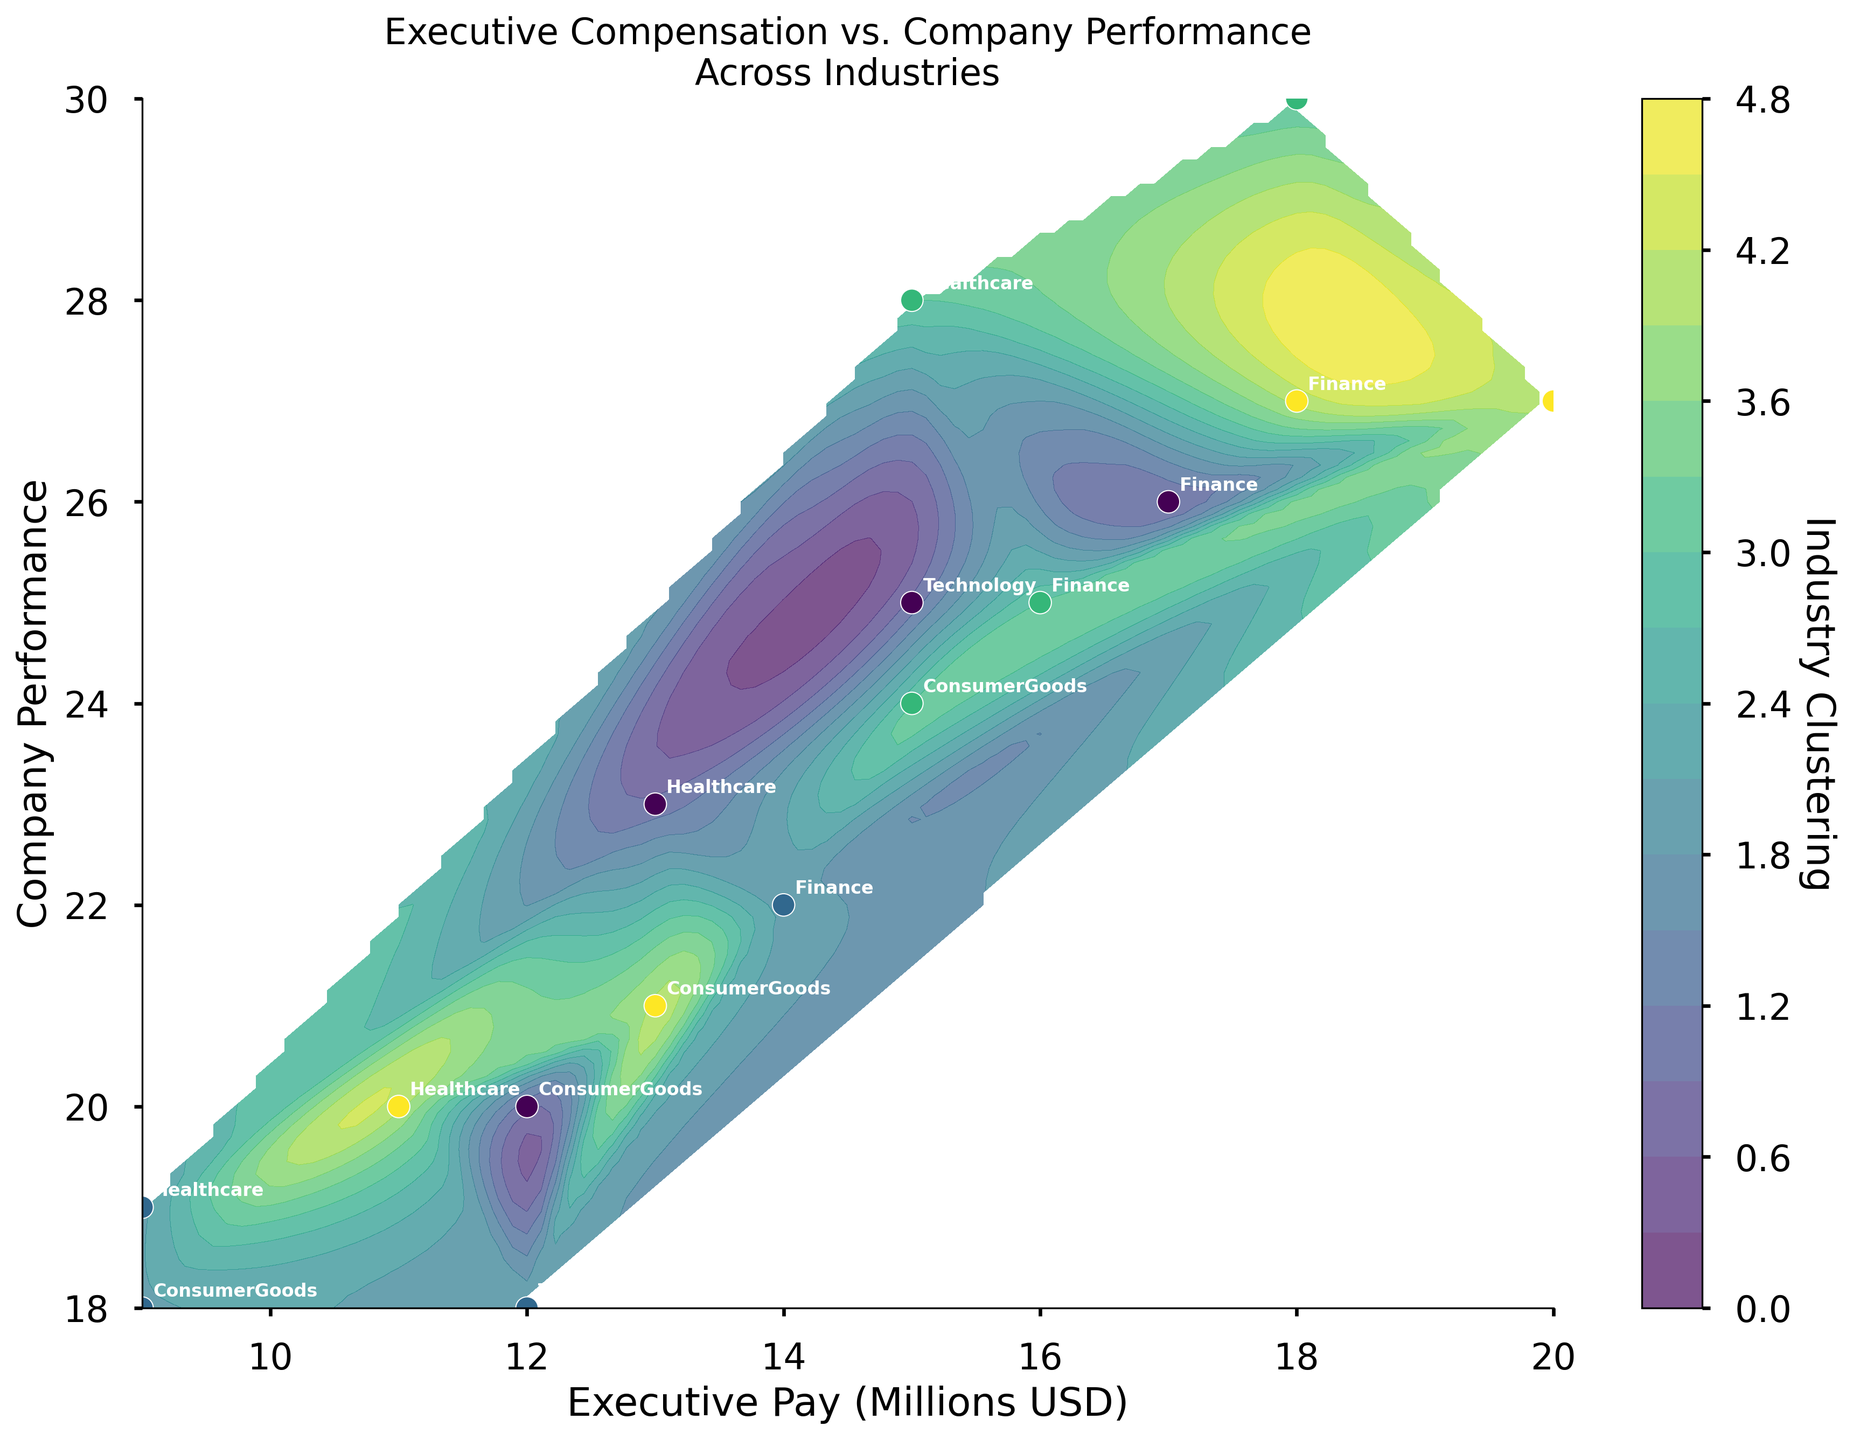What is the title of the chart? The title of the chart is usually found at the top and provides a concise summary of the data being presented. In this case, it states the main subject of the figure, which is "Executive Compensation vs. Company Performance Across Industries".
Answer: Executive Compensation vs. Company Performance Across Industries What are the labels of the x and y axes? The labels for the x and y axes are typically found along the axes of the chart. They describe what those axes represent. The x-axis represents "Executive Pay (Millions USD)" and the y-axis represents "Company Performance".
Answer: Executive Pay (Millions USD), Company Performance How many distinct industries are represented in the plot? Each industry is represented by clusters of data points, and each cluster is labeled with the industry name. By counting the distinct labels, one can determine the number of industries.
Answer: 4 Which industry shows the highest company performance for a given executive pay? To identify this, look for the data points corresponding to the highest value on the y-axis and see which industry label is attached to those points.
Answer: Technology Between the finance and healthcare industries, which one has more variability in executive pay? Variability can be observed by the spread of data points along the x-axis for each industry. Compare the spread of the finance industry points to the healthcare industry points on the x-axis.
Answer: Finance What is the executive pay range for the Technology industry? To find the range, identify the minimum and maximum executive pay values for the Technology industry data points. This can be observed on the x-axis where these points are located.
Answer: 12 to 20 million USD How does the clustering of industries appear to differ in terms of company performance? Look at the contour lines and the clustering of data points for different industries along the y-axis to see how closely or broadly they are dispersed, and identify any distinct patterns.
Answer: Technology and Finance are more dispersed, while Healthcare and Consumer Goods are more clustered For the Consumer Goods industry, what is the average company performance? Average company performance can be calculated by summing up the company performance values for the Consumer Goods data points and dividing by the number of points. The data points for Consumer Goods have performance values of 20, 18, 24, and 21, so compute (20 + 18 + 24 + 21) / 4.
Answer: 20.75 Which industry has the lowest executive pay for the highest company performance? Identify the data points with the highest company performance on the y-axis, then find the one with the lowest executive pay on the x-axis among those points, and check the industry label.
Answer: Healthcare 